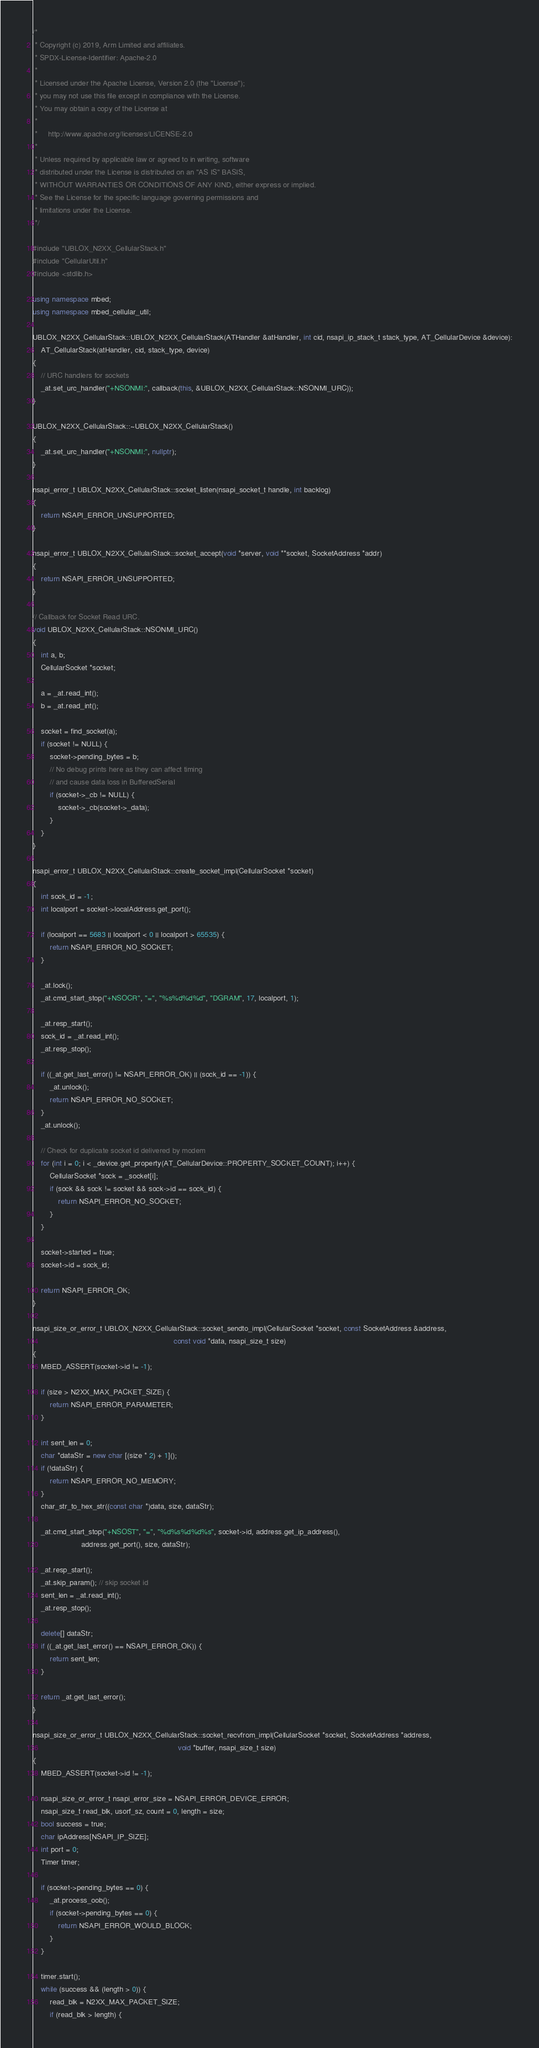<code> <loc_0><loc_0><loc_500><loc_500><_C++_>/*
 * Copyright (c) 2019, Arm Limited and affiliates.
 * SPDX-License-Identifier: Apache-2.0
 *
 * Licensed under the Apache License, Version 2.0 (the "License");
 * you may not use this file except in compliance with the License.
 * You may obtain a copy of the License at
 *
 *     http://www.apache.org/licenses/LICENSE-2.0
 *
 * Unless required by applicable law or agreed to in writing, software
 * distributed under the License is distributed on an "AS IS" BASIS,
 * WITHOUT WARRANTIES OR CONDITIONS OF ANY KIND, either express or implied.
 * See the License for the specific language governing permissions and
 * limitations under the License.
 */

#include "UBLOX_N2XX_CellularStack.h"
#include "CellularUtil.h"
#include <stdlib.h>

using namespace mbed;
using namespace mbed_cellular_util;

UBLOX_N2XX_CellularStack::UBLOX_N2XX_CellularStack(ATHandler &atHandler, int cid, nsapi_ip_stack_t stack_type, AT_CellularDevice &device):
    AT_CellularStack(atHandler, cid, stack_type, device)
{
    // URC handlers for sockets
    _at.set_urc_handler("+NSONMI:", callback(this, &UBLOX_N2XX_CellularStack::NSONMI_URC));
}

UBLOX_N2XX_CellularStack::~UBLOX_N2XX_CellularStack()
{
    _at.set_urc_handler("+NSONMI:", nullptr);
}

nsapi_error_t UBLOX_N2XX_CellularStack::socket_listen(nsapi_socket_t handle, int backlog)
{
    return NSAPI_ERROR_UNSUPPORTED;
}

nsapi_error_t UBLOX_N2XX_CellularStack::socket_accept(void *server, void **socket, SocketAddress *addr)
{
    return NSAPI_ERROR_UNSUPPORTED;
}

// Callback for Socket Read URC.
void UBLOX_N2XX_CellularStack::NSONMI_URC()
{
    int a, b;
    CellularSocket *socket;

    a = _at.read_int();
    b = _at.read_int();

    socket = find_socket(a);
    if (socket != NULL) {
        socket->pending_bytes = b;
        // No debug prints here as they can affect timing
        // and cause data loss in BufferedSerial
        if (socket->_cb != NULL) {
            socket->_cb(socket->_data);
        }
    }
}

nsapi_error_t UBLOX_N2XX_CellularStack::create_socket_impl(CellularSocket *socket)
{
    int sock_id = -1;
    int localport = socket->localAddress.get_port();

    if (localport == 5683 || localport < 0 || localport > 65535) {
        return NSAPI_ERROR_NO_SOCKET;
    }

    _at.lock();
    _at.cmd_start_stop("+NSOCR", "=", "%s%d%d%d", "DGRAM", 17, localport, 1);

    _at.resp_start();
    sock_id = _at.read_int();
    _at.resp_stop();

    if ((_at.get_last_error() != NSAPI_ERROR_OK) || (sock_id == -1)) {
        _at.unlock();
        return NSAPI_ERROR_NO_SOCKET;
    }
    _at.unlock();

    // Check for duplicate socket id delivered by modem
    for (int i = 0; i < _device.get_property(AT_CellularDevice::PROPERTY_SOCKET_COUNT); i++) {
        CellularSocket *sock = _socket[i];
        if (sock && sock != socket && sock->id == sock_id) {
            return NSAPI_ERROR_NO_SOCKET;
        }
    }

    socket->started = true;
    socket->id = sock_id;

    return NSAPI_ERROR_OK;
}

nsapi_size_or_error_t UBLOX_N2XX_CellularStack::socket_sendto_impl(CellularSocket *socket, const SocketAddress &address,
                                                                   const void *data, nsapi_size_t size)
{
    MBED_ASSERT(socket->id != -1);

    if (size > N2XX_MAX_PACKET_SIZE) {
        return NSAPI_ERROR_PARAMETER;
    }

    int sent_len = 0;
    char *dataStr = new char [(size * 2) + 1]();
    if (!dataStr) {
        return NSAPI_ERROR_NO_MEMORY;
    }
    char_str_to_hex_str((const char *)data, size, dataStr);

    _at.cmd_start_stop("+NSOST", "=", "%d%s%d%d%s", socket->id, address.get_ip_address(),
                       address.get_port(), size, dataStr);

    _at.resp_start();
    _at.skip_param(); // skip socket id
    sent_len = _at.read_int();
    _at.resp_stop();

    delete[] dataStr;
    if ((_at.get_last_error() == NSAPI_ERROR_OK)) {
        return sent_len;
    }

    return _at.get_last_error();
}

nsapi_size_or_error_t UBLOX_N2XX_CellularStack::socket_recvfrom_impl(CellularSocket *socket, SocketAddress *address,
                                                                     void *buffer, nsapi_size_t size)
{
    MBED_ASSERT(socket->id != -1);

    nsapi_size_or_error_t nsapi_error_size = NSAPI_ERROR_DEVICE_ERROR;
    nsapi_size_t read_blk, usorf_sz, count = 0, length = size;
    bool success = true;
    char ipAddress[NSAPI_IP_SIZE];
    int port = 0;
    Timer timer;

    if (socket->pending_bytes == 0) {
        _at.process_oob();
        if (socket->pending_bytes == 0) {
            return NSAPI_ERROR_WOULD_BLOCK;
        }
    }

    timer.start();
    while (success && (length > 0)) {
        read_blk = N2XX_MAX_PACKET_SIZE;
        if (read_blk > length) {</code> 